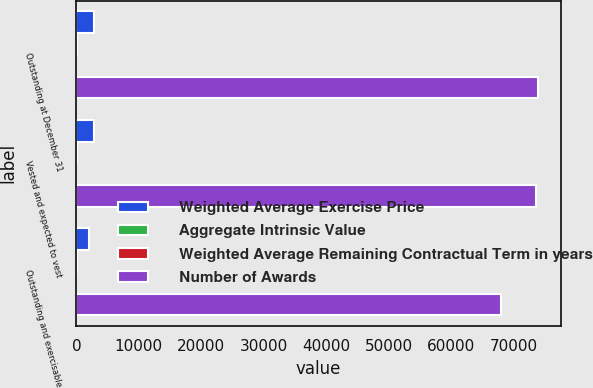Convert chart. <chart><loc_0><loc_0><loc_500><loc_500><stacked_bar_chart><ecel><fcel>Outstanding at December 31<fcel>Vested and expected to vest<fcel>Outstanding and exercisable<nl><fcel>Weighted Average Exercise Price<fcel>2849<fcel>2786<fcel>2085<nl><fcel>Aggregate Intrinsic Value<fcel>43.7<fcel>43.18<fcel>36.98<nl><fcel>Weighted Average Remaining Contractual Term in years<fcel>4.03<fcel>3.97<fcel>3.24<nl><fcel>Number of Awards<fcel>73871<fcel>73687<fcel>68072<nl></chart> 